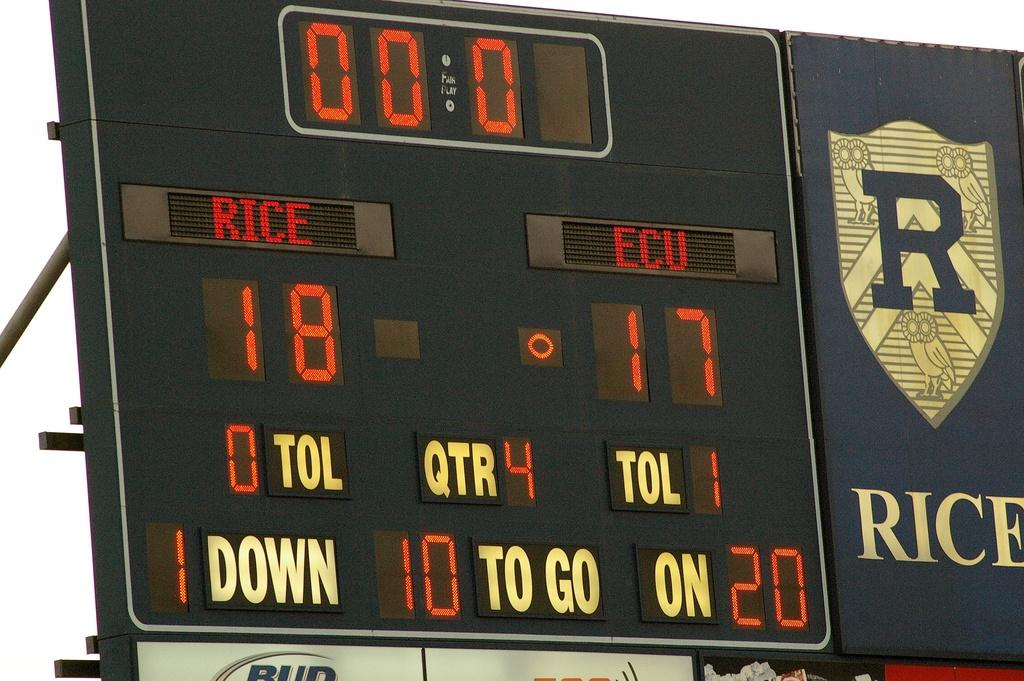<image>
Describe the image concisely. A score board shows Rice with 18 points vs. ECU with 17 points. 